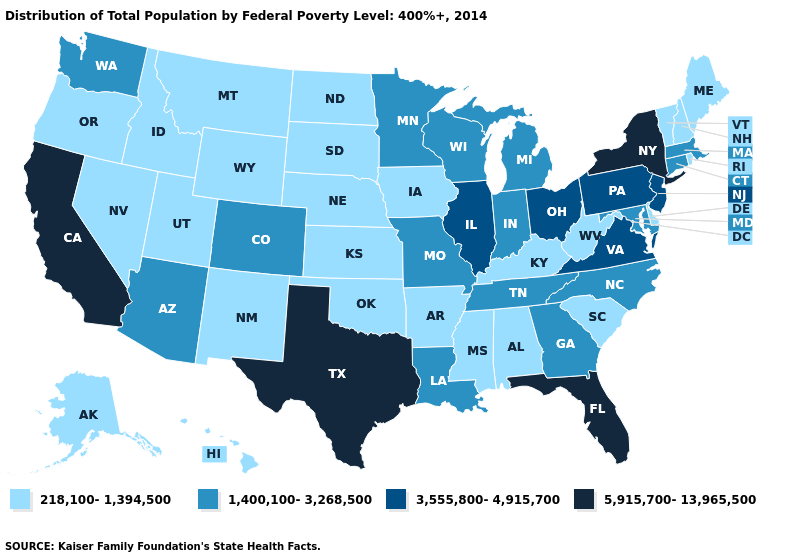Does West Virginia have a lower value than Nevada?
Answer briefly. No. Does California have the highest value in the West?
Be succinct. Yes. Among the states that border Nevada , which have the highest value?
Write a very short answer. California. What is the value of Oklahoma?
Keep it brief. 218,100-1,394,500. What is the highest value in the West ?
Give a very brief answer. 5,915,700-13,965,500. Name the states that have a value in the range 218,100-1,394,500?
Keep it brief. Alabama, Alaska, Arkansas, Delaware, Hawaii, Idaho, Iowa, Kansas, Kentucky, Maine, Mississippi, Montana, Nebraska, Nevada, New Hampshire, New Mexico, North Dakota, Oklahoma, Oregon, Rhode Island, South Carolina, South Dakota, Utah, Vermont, West Virginia, Wyoming. What is the highest value in the MidWest ?
Concise answer only. 3,555,800-4,915,700. What is the value of West Virginia?
Keep it brief. 218,100-1,394,500. What is the lowest value in the South?
Give a very brief answer. 218,100-1,394,500. What is the value of Massachusetts?
Keep it brief. 1,400,100-3,268,500. Name the states that have a value in the range 1,400,100-3,268,500?
Answer briefly. Arizona, Colorado, Connecticut, Georgia, Indiana, Louisiana, Maryland, Massachusetts, Michigan, Minnesota, Missouri, North Carolina, Tennessee, Washington, Wisconsin. Which states hav the highest value in the MidWest?
Be succinct. Illinois, Ohio. Does South Carolina have the lowest value in the USA?
Short answer required. Yes. What is the highest value in the West ?
Be succinct. 5,915,700-13,965,500. 